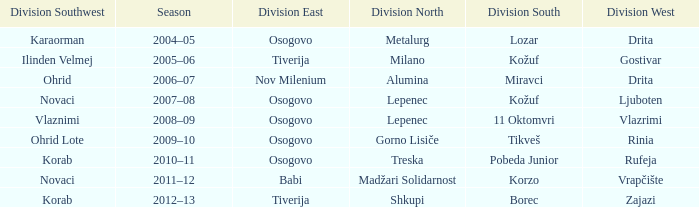Who won Division West when Division North was won by Alumina? Drita. 